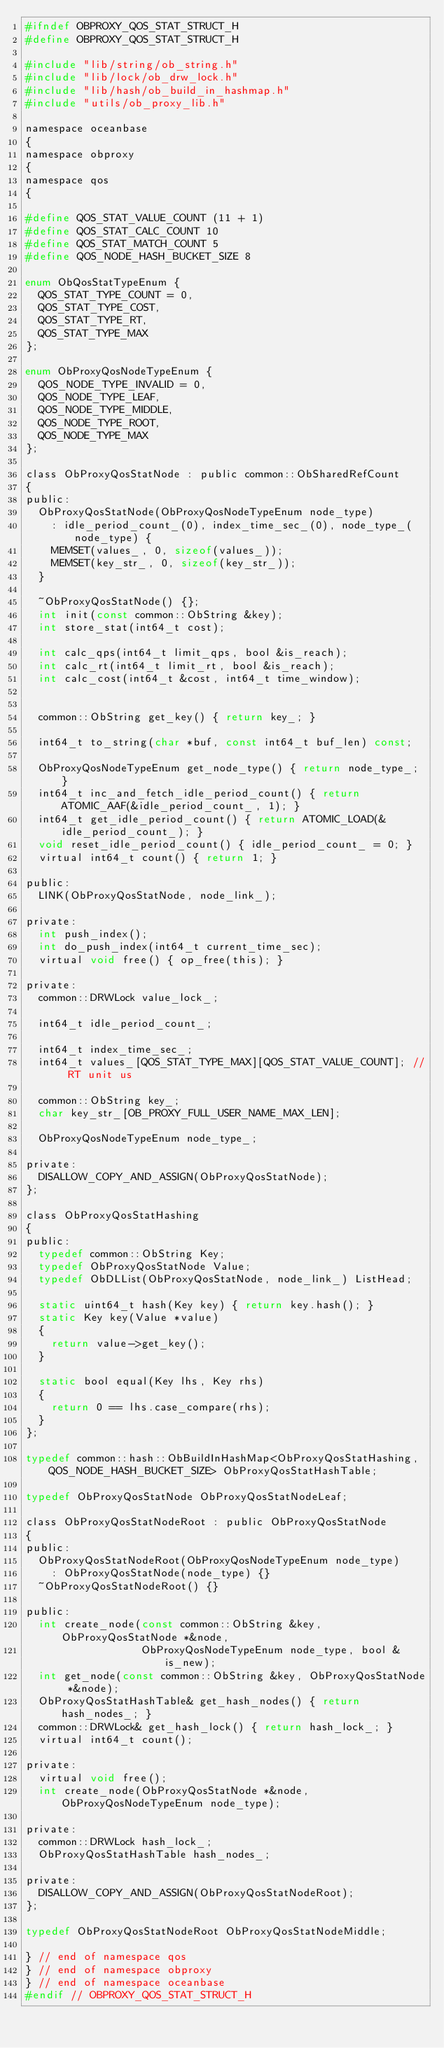<code> <loc_0><loc_0><loc_500><loc_500><_C_>#ifndef OBPROXY_QOS_STAT_STRUCT_H
#define OBPROXY_QOS_STAT_STRUCT_H

#include "lib/string/ob_string.h"
#include "lib/lock/ob_drw_lock.h"
#include "lib/hash/ob_build_in_hashmap.h"
#include "utils/ob_proxy_lib.h"

namespace oceanbase
{
namespace obproxy
{
namespace qos
{

#define QOS_STAT_VALUE_COUNT (11 + 1)
#define QOS_STAT_CALC_COUNT 10
#define QOS_STAT_MATCH_COUNT 5
#define QOS_NODE_HASH_BUCKET_SIZE 8

enum ObQosStatTypeEnum {
  QOS_STAT_TYPE_COUNT = 0,
  QOS_STAT_TYPE_COST,
  QOS_STAT_TYPE_RT,
  QOS_STAT_TYPE_MAX
};

enum ObProxyQosNodeTypeEnum {
  QOS_NODE_TYPE_INVALID = 0,
  QOS_NODE_TYPE_LEAF,
  QOS_NODE_TYPE_MIDDLE,
  QOS_NODE_TYPE_ROOT,
  QOS_NODE_TYPE_MAX
};

class ObProxyQosStatNode : public common::ObSharedRefCount
{
public:
  ObProxyQosStatNode(ObProxyQosNodeTypeEnum node_type)
    : idle_period_count_(0), index_time_sec_(0), node_type_(node_type) {
    MEMSET(values_, 0, sizeof(values_));
    MEMSET(key_str_, 0, sizeof(key_str_));
  }

  ~ObProxyQosStatNode() {};
  int init(const common::ObString &key);
  int store_stat(int64_t cost);

  int calc_qps(int64_t limit_qps, bool &is_reach);
  int calc_rt(int64_t limit_rt, bool &is_reach);
  int calc_cost(int64_t &cost, int64_t time_window);


  common::ObString get_key() { return key_; }

  int64_t to_string(char *buf, const int64_t buf_len) const;

  ObProxyQosNodeTypeEnum get_node_type() { return node_type_; }
  int64_t inc_and_fetch_idle_period_count() { return ATOMIC_AAF(&idle_period_count_, 1); }
  int64_t get_idle_period_count() { return ATOMIC_LOAD(&idle_period_count_); }
  void reset_idle_period_count() { idle_period_count_ = 0; }
  virtual int64_t count() { return 1; }

public:
  LINK(ObProxyQosStatNode, node_link_);

private:
  int push_index();
  int do_push_index(int64_t current_time_sec);
  virtual void free() { op_free(this); }

private:
  common::DRWLock value_lock_;

  int64_t idle_period_count_;

  int64_t index_time_sec_;
  int64_t values_[QOS_STAT_TYPE_MAX][QOS_STAT_VALUE_COUNT]; // RT unit us

  common::ObString key_;
  char key_str_[OB_PROXY_FULL_USER_NAME_MAX_LEN];

  ObProxyQosNodeTypeEnum node_type_;

private:
  DISALLOW_COPY_AND_ASSIGN(ObProxyQosStatNode);
};

class ObProxyQosStatHashing
{
public:
  typedef common::ObString Key;
  typedef ObProxyQosStatNode Value;
  typedef ObDLList(ObProxyQosStatNode, node_link_) ListHead;

  static uint64_t hash(Key key) { return key.hash(); }
  static Key key(Value *value)
  {
    return value->get_key();
  }

  static bool equal(Key lhs, Key rhs)
  {
    return 0 == lhs.case_compare(rhs);
  }
};

typedef common::hash::ObBuildInHashMap<ObProxyQosStatHashing, QOS_NODE_HASH_BUCKET_SIZE> ObProxyQosStatHashTable;

typedef ObProxyQosStatNode ObProxyQosStatNodeLeaf;

class ObProxyQosStatNodeRoot : public ObProxyQosStatNode
{
public:
  ObProxyQosStatNodeRoot(ObProxyQosNodeTypeEnum node_type)
    : ObProxyQosStatNode(node_type) {}
  ~ObProxyQosStatNodeRoot() {}

public:
  int create_node(const common::ObString &key, ObProxyQosStatNode *&node,
                  ObProxyQosNodeTypeEnum node_type, bool &is_new);
  int get_node(const common::ObString &key, ObProxyQosStatNode *&node);
  ObProxyQosStatHashTable& get_hash_nodes() { return hash_nodes_; }
  common::DRWLock& get_hash_lock() { return hash_lock_; }
  virtual int64_t count();

private:
  virtual void free();
  int create_node(ObProxyQosStatNode *&node, ObProxyQosNodeTypeEnum node_type);

private:
  common::DRWLock hash_lock_;
  ObProxyQosStatHashTable hash_nodes_;

private:
  DISALLOW_COPY_AND_ASSIGN(ObProxyQosStatNodeRoot);
};

typedef ObProxyQosStatNodeRoot ObProxyQosStatNodeMiddle;

} // end of namespace qos
} // end of namespace obproxy
} // end of namespace oceanbase
#endif // OBPROXY_QOS_STAT_STRUCT_H
</code> 